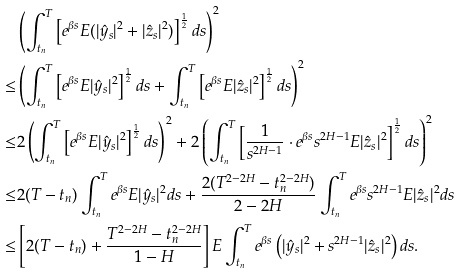<formula> <loc_0><loc_0><loc_500><loc_500>& \left ( \int _ { t _ { n } } ^ { T } \left [ e ^ { \beta s } E ( | \hat { y } _ { s } | ^ { 2 } + | \hat { z } _ { s } | ^ { 2 } ) \right ] ^ { \frac { 1 } { 2 } } d s \right ) ^ { 2 } \\ \leq & \left ( \int _ { t _ { n } } ^ { T } \left [ e ^ { \beta s } E | \hat { y } _ { s } | ^ { 2 } \right ] ^ { \frac { 1 } { 2 } } d s + \int _ { t _ { n } } ^ { T } \left [ e ^ { \beta s } E | \hat { z } _ { s } | ^ { 2 } \right ] ^ { \frac { 1 } { 2 } } d s \right ) ^ { 2 } \\ \leq & 2 \left ( \int _ { t _ { n } } ^ { T } \left [ e ^ { \beta s } E | \hat { y } _ { s } | ^ { 2 } \right ] ^ { \frac { 1 } { 2 } } d s \right ) ^ { 2 } + 2 \left ( \int _ { t _ { n } } ^ { T } \left [ \frac { 1 } { s ^ { 2 H - 1 } } \cdot e ^ { \beta s } s ^ { 2 H - 1 } E | \hat { z } _ { s } | ^ { 2 } \right ] ^ { \frac { 1 } { 2 } } d s \right ) ^ { 2 } \\ \leq & 2 ( T - t _ { n } ) \int _ { t _ { n } } ^ { T } e ^ { \beta s } E | \hat { y } _ { s } | ^ { 2 } d s + \frac { 2 ( T ^ { 2 - 2 H } - t _ { n } ^ { 2 - 2 H } ) } { 2 - 2 H } \int _ { t _ { n } } ^ { T } e ^ { \beta s } s ^ { 2 H - 1 } E | \hat { z } _ { s } | ^ { 2 } d s \\ \leq & \left [ 2 ( T - t _ { n } ) + \frac { T ^ { 2 - 2 H } - t _ { n } ^ { 2 - 2 H } } { 1 - H } \right ] E \int _ { t _ { n } } ^ { T } e ^ { \beta s } \left ( | \hat { y } _ { s } | ^ { 2 } + s ^ { 2 H - 1 } | \hat { z } _ { s } | ^ { 2 } \right ) d s .</formula> 